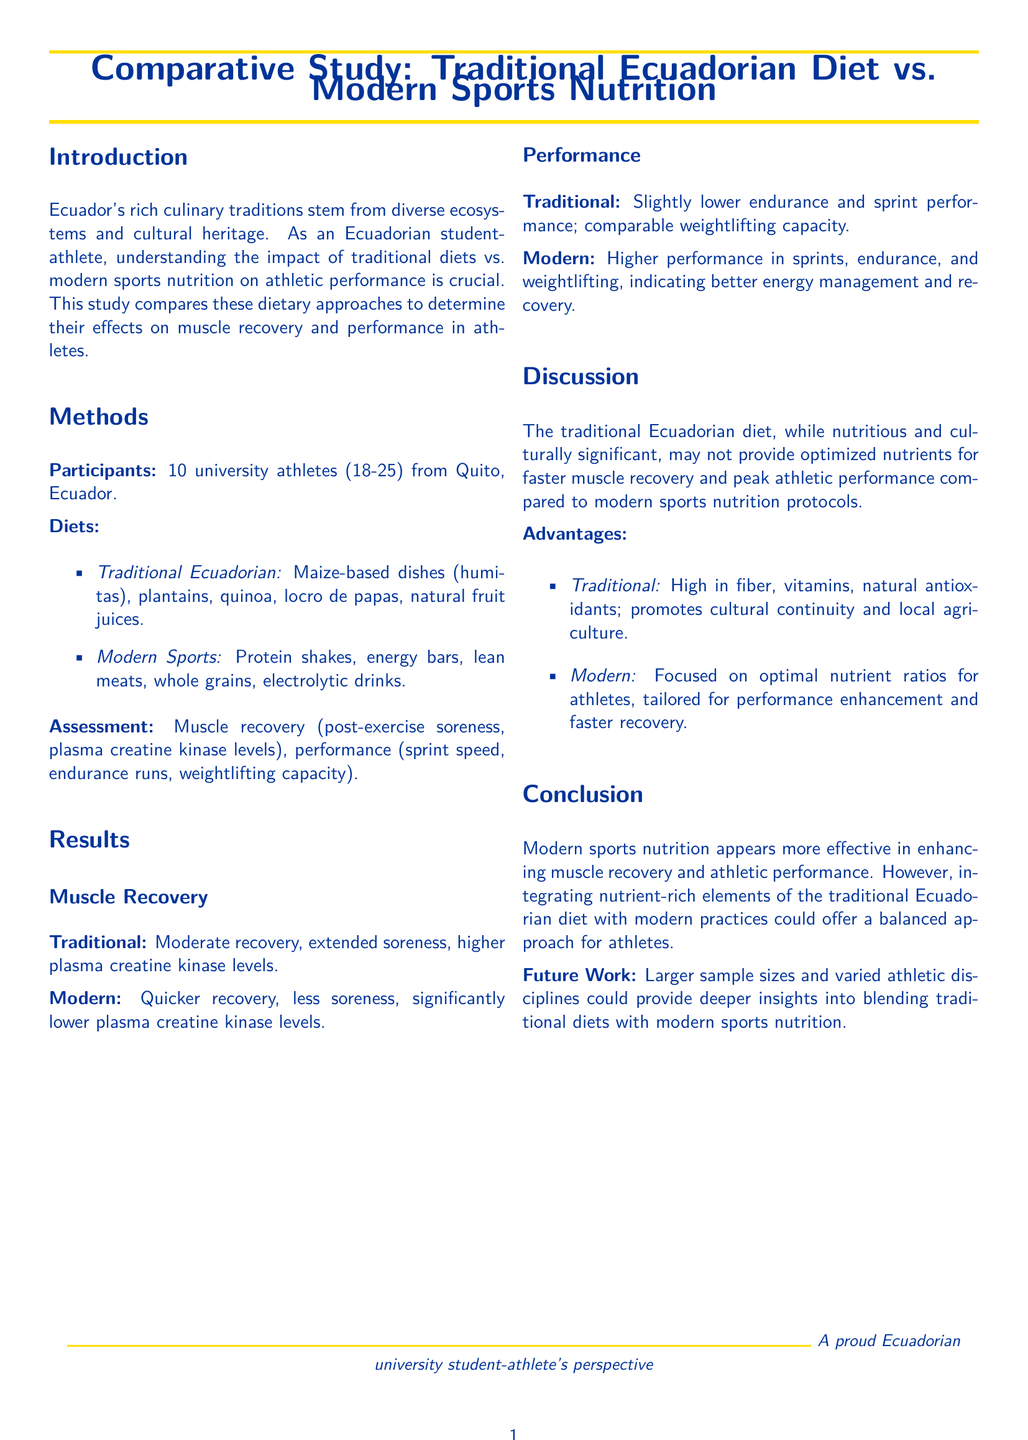What is the focus of this study? The study focuses on comparing the effects of traditional Ecuadorian diet and modern sports nutrition on muscle recovery and performance in athletes.
Answer: Comparing diets How many university athletes participated in the study? The number of participants is explicitly stated in the document as 10 university athletes.
Answer: 10 What type of dishes are included in the traditional Ecuadorian diet? Specific examples of food items included in the traditional diet are mentioned, such as maize-based dishes, plantains, and quinoa.
Answer: Maize-based dishes, plantains, quinoa Which diet showed quicker muscle recovery? The results section specifies that the modern sports nutrition diet led to quicker muscle recovery compared to the traditional diet.
Answer: Modern What was a significant advantage of the traditional Ecuadorian diet? The document states that one of the advantages is that it is high in fiber, vitamins, and natural antioxidants.
Answer: High in fiber, vitamins, natural antioxidants What category of performance was higher in the modern diet? The document notes that the modern sports diet led to higher performance in sprints, endurance, and weightlifting.
Answer: Sprints, endurance, weightlifting What does the study suggest for future work? The conclusion suggests that larger sample sizes and varied athletic disciplines could enhance understanding of diet blending.
Answer: Larger sample sizes, varied disciplines What was the age range of the participants? The age range of participants is specified in the methods section as between 18 and 25 years old.
Answer: 18-25 